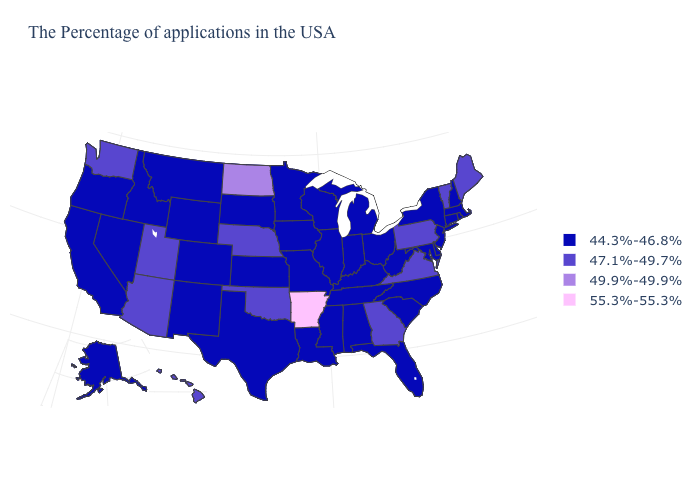Among the states that border Vermont , which have the highest value?
Give a very brief answer. Massachusetts, New Hampshire, New York. What is the value of Nebraska?
Quick response, please. 47.1%-49.7%. Is the legend a continuous bar?
Keep it brief. No. Name the states that have a value in the range 55.3%-55.3%?
Write a very short answer. Arkansas. Name the states that have a value in the range 55.3%-55.3%?
Answer briefly. Arkansas. Does Arkansas have the highest value in the USA?
Quick response, please. Yes. Which states have the lowest value in the USA?
Keep it brief. Massachusetts, Rhode Island, New Hampshire, Connecticut, New York, New Jersey, Delaware, Maryland, North Carolina, South Carolina, West Virginia, Ohio, Florida, Michigan, Kentucky, Indiana, Alabama, Tennessee, Wisconsin, Illinois, Mississippi, Louisiana, Missouri, Minnesota, Iowa, Kansas, Texas, South Dakota, Wyoming, Colorado, New Mexico, Montana, Idaho, Nevada, California, Oregon, Alaska. Name the states that have a value in the range 55.3%-55.3%?
Keep it brief. Arkansas. Does the first symbol in the legend represent the smallest category?
Write a very short answer. Yes. What is the lowest value in the USA?
Answer briefly. 44.3%-46.8%. Does West Virginia have the same value as Oregon?
Short answer required. Yes. What is the highest value in the USA?
Write a very short answer. 55.3%-55.3%. Does Ohio have the lowest value in the USA?
Quick response, please. Yes. Among the states that border New York , does Pennsylvania have the lowest value?
Keep it brief. No. Name the states that have a value in the range 47.1%-49.7%?
Write a very short answer. Maine, Vermont, Pennsylvania, Virginia, Georgia, Nebraska, Oklahoma, Utah, Arizona, Washington, Hawaii. 